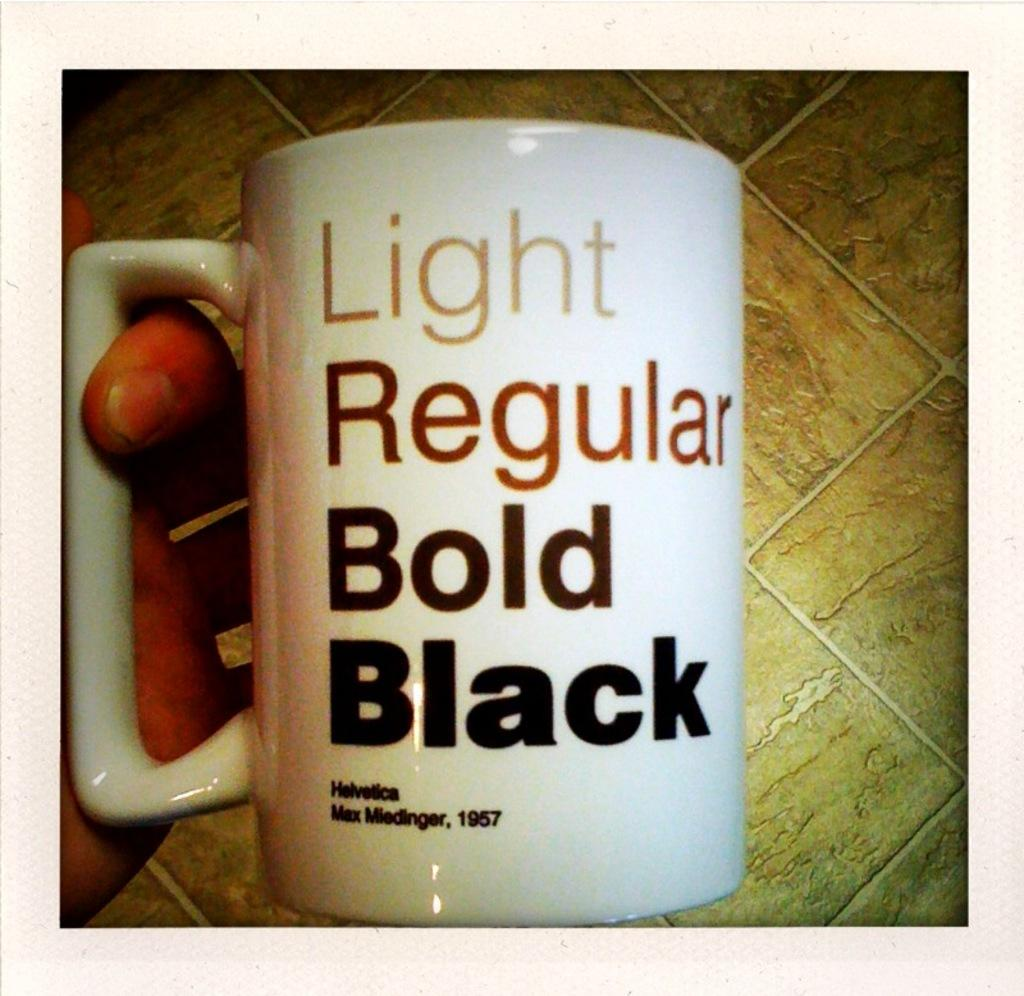<image>
Describe the image concisely. A coffee cup that reads Light, regular, bold and black. 